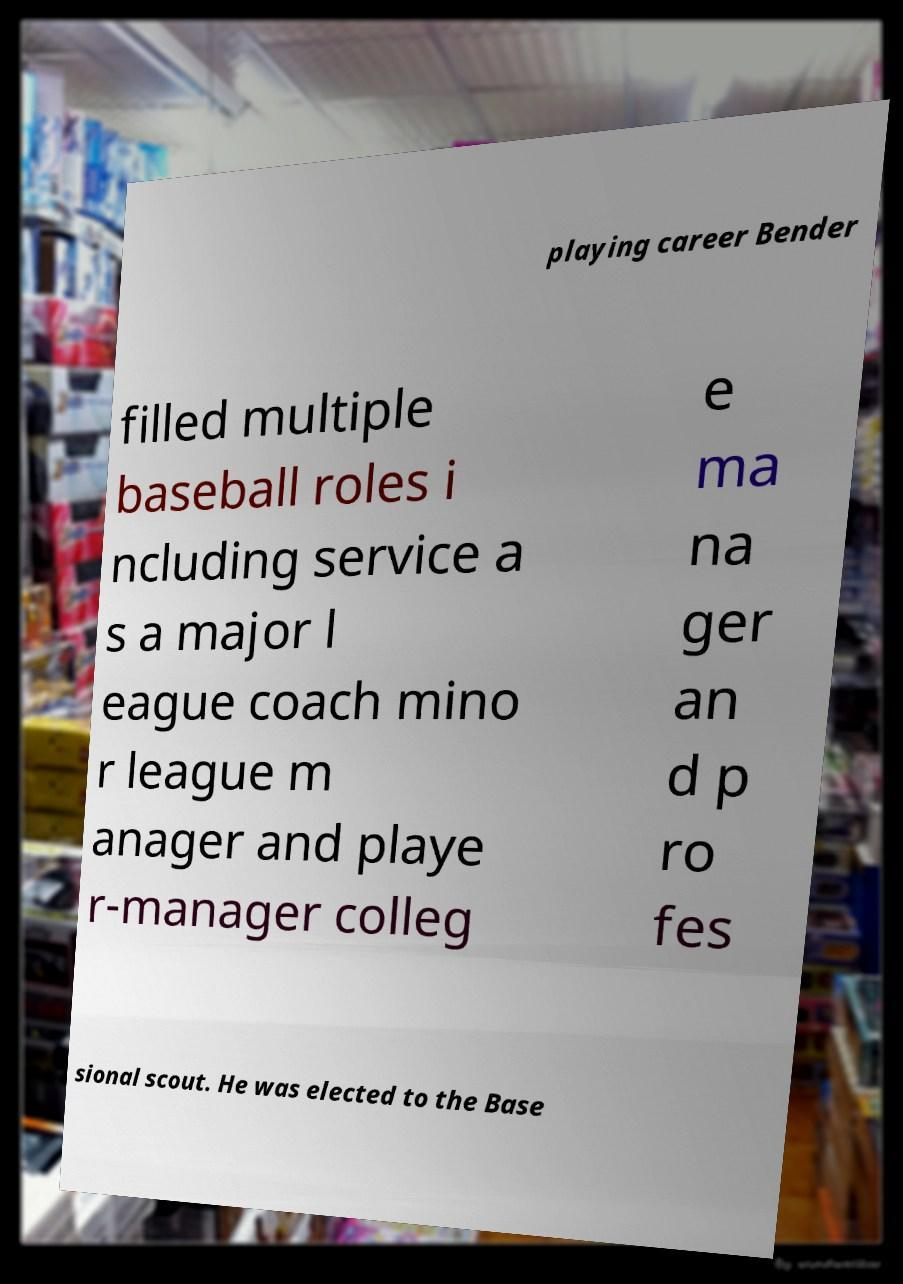Could you extract and type out the text from this image? playing career Bender filled multiple baseball roles i ncluding service a s a major l eague coach mino r league m anager and playe r-manager colleg e ma na ger an d p ro fes sional scout. He was elected to the Base 